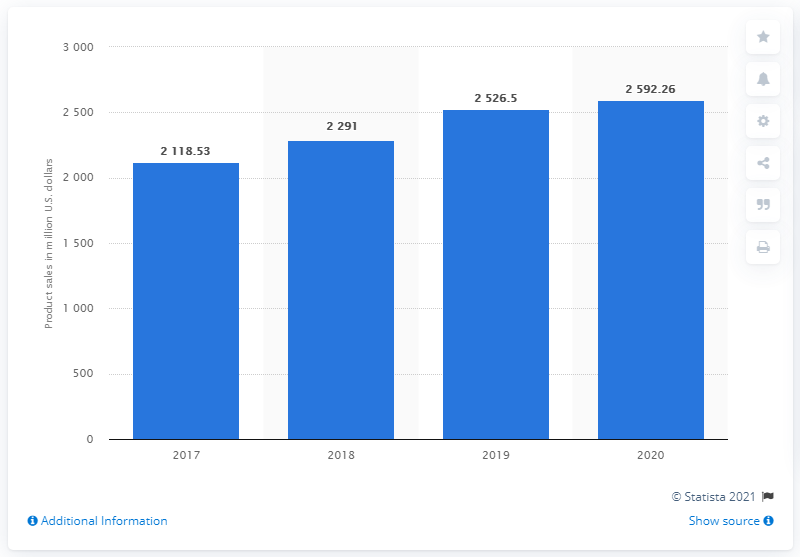Indicate a few pertinent items in this graphic. Guess, Inc. reported net product sales of $2592.26 in 2020. The net product sales of Guess, Inc. in 2019 were $25,26.5 million. 